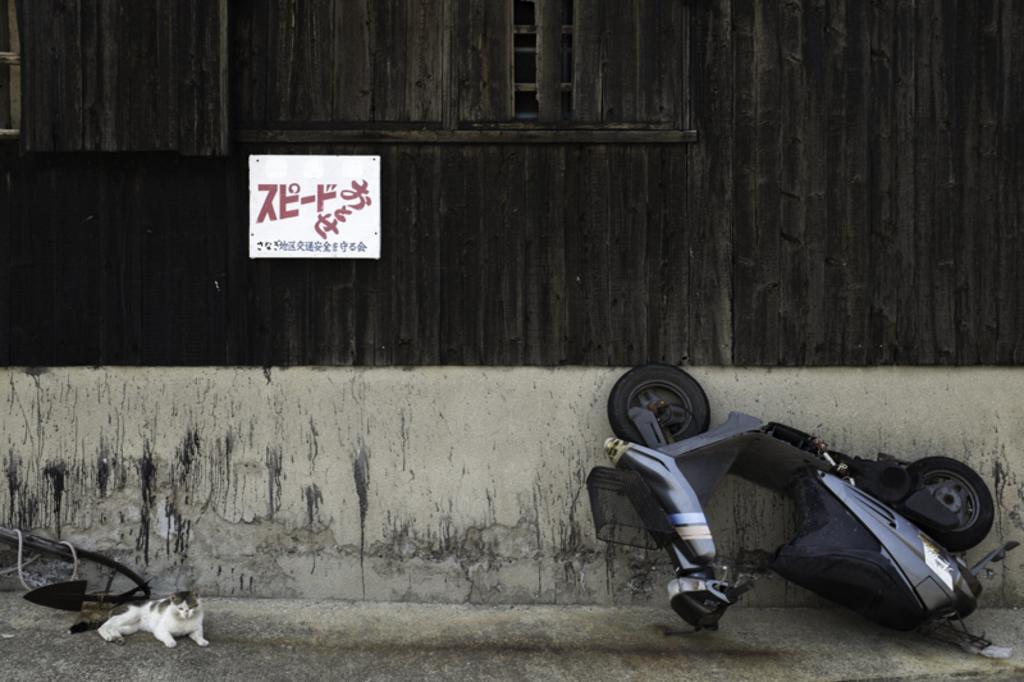In one or two sentences, can you explain what this image depicts? In this image we can see a scooter on the right side. On the left side there is a cat and some other object. In the back there is a wall with wooden pieces. Also there is a board with something written on the wall. 